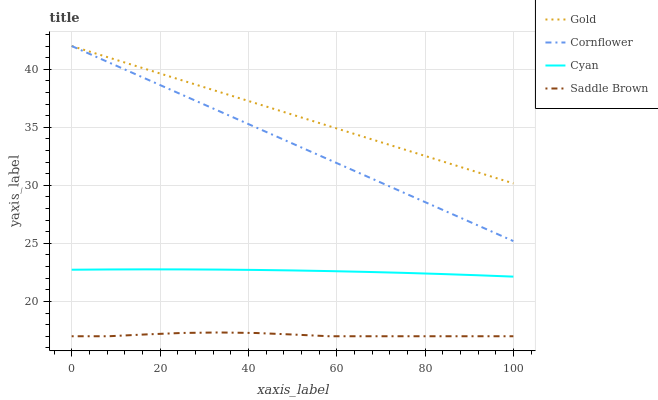Does Saddle Brown have the minimum area under the curve?
Answer yes or no. Yes. Does Gold have the maximum area under the curve?
Answer yes or no. Yes. Does Gold have the minimum area under the curve?
Answer yes or no. No. Does Saddle Brown have the maximum area under the curve?
Answer yes or no. No. Is Gold the smoothest?
Answer yes or no. Yes. Is Saddle Brown the roughest?
Answer yes or no. Yes. Is Saddle Brown the smoothest?
Answer yes or no. No. Is Gold the roughest?
Answer yes or no. No. Does Saddle Brown have the lowest value?
Answer yes or no. Yes. Does Gold have the lowest value?
Answer yes or no. No. Does Gold have the highest value?
Answer yes or no. Yes. Does Saddle Brown have the highest value?
Answer yes or no. No. Is Saddle Brown less than Cornflower?
Answer yes or no. Yes. Is Cornflower greater than Saddle Brown?
Answer yes or no. Yes. Does Cornflower intersect Gold?
Answer yes or no. Yes. Is Cornflower less than Gold?
Answer yes or no. No. Is Cornflower greater than Gold?
Answer yes or no. No. Does Saddle Brown intersect Cornflower?
Answer yes or no. No. 